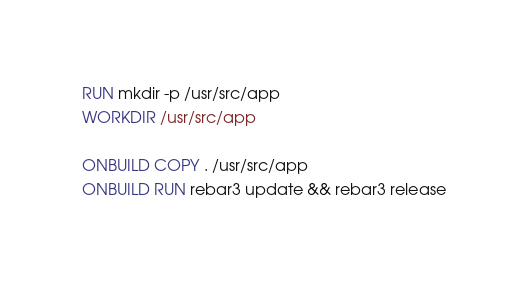<code> <loc_0><loc_0><loc_500><loc_500><_Dockerfile_>RUN mkdir -p /usr/src/app
WORKDIR /usr/src/app

ONBUILD COPY . /usr/src/app
ONBUILD RUN rebar3 update && rebar3 release
</code> 